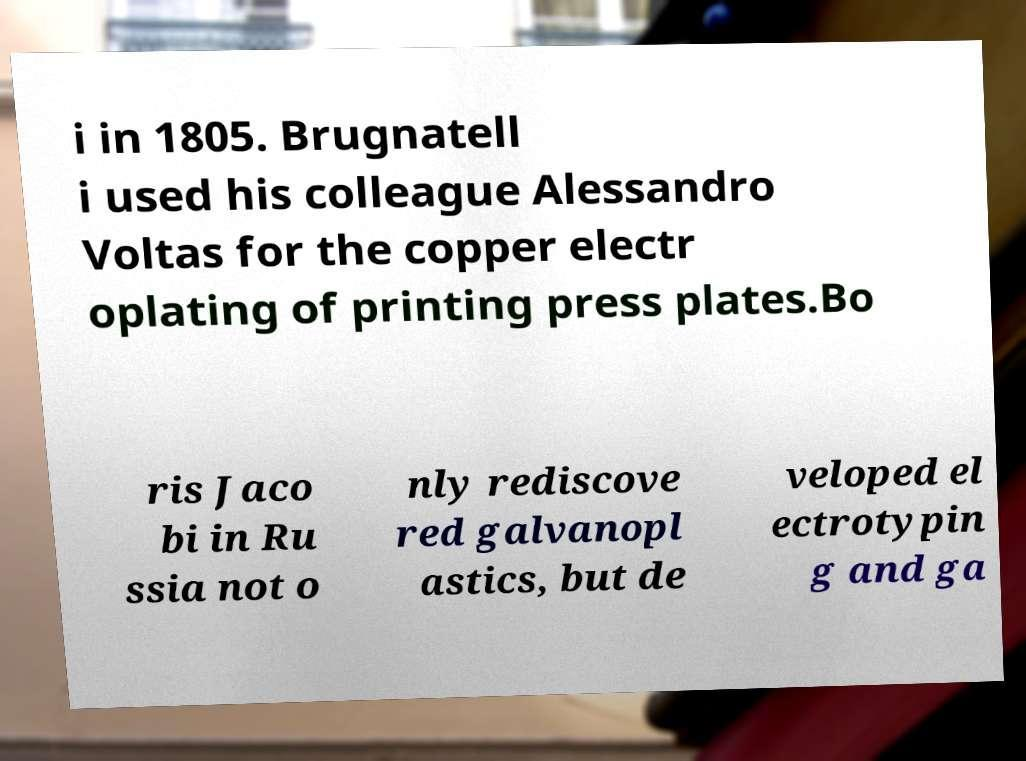Can you accurately transcribe the text from the provided image for me? i in 1805. Brugnatell i used his colleague Alessandro Voltas for the copper electr oplating of printing press plates.Bo ris Jaco bi in Ru ssia not o nly rediscove red galvanopl astics, but de veloped el ectrotypin g and ga 